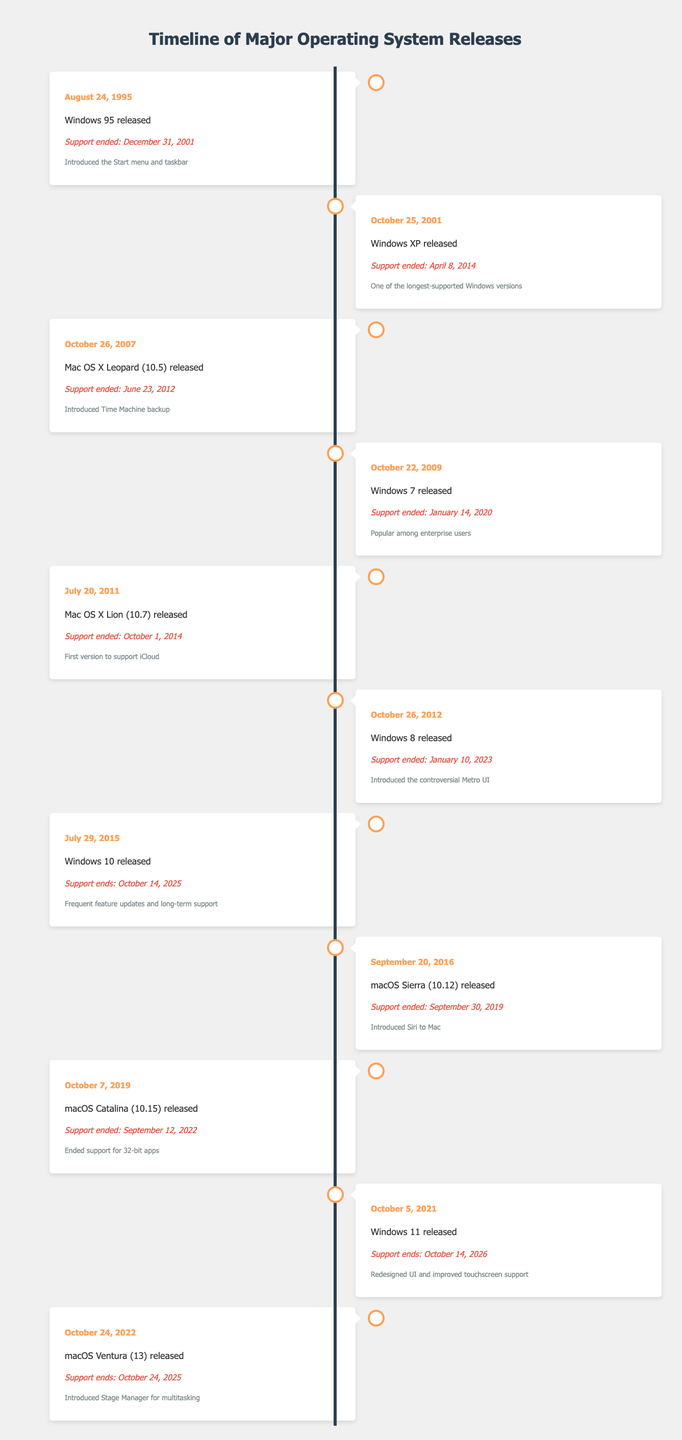What was the support end date for Windows 7? According to the table, Windows 7 was released on October 22, 2009, and the support ended on January 14, 2020, as listed in the support end column.
Answer: January 14, 2020 Which macOS version introduced Siri? The table indicates that macOS Sierra (10.12) released on September 20, 2016, was the version that introduced Siri to Mac, as noted in the observations section for that release.
Answer: macOS Sierra (10.12) How many years did Windows XP receive support? Windows XP was released on October 25, 2001, and its support ended on April 8, 2014. To find the support duration, we calculate the difference between the release date and the support end date: 2014 - 2001 = 13 years, plus the months and days, it totals to around 12 years and 5 months of support.
Answer: Approximately 12 years and 5 months Is macOS Ventura the latest version in the timeline? The timeline presents events up to October 24, 2022, when macOS Ventura (13) was released. Since there are no events listed after this date, we conclude that macOS Ventura is the latest version in this timeline.
Answer: Yes How many operating systems released in 2015 and their support end dates? From the table, only one operating system was released in 2015, which is Windows 10 on July 29, 2015. Its support end date is October 14, 2025. Therefore, there is one OS released in 2015, and the support end date is noted accordingly.
Answer: One OS, October 14, 2025 What is the total duration of support for Windows 8? Windows 8 was released on October 26, 2012, and its support ended on January 10, 2023. To calculate the duration, we'll find the difference between these dates: From October 26, 2012, to October 26, 2022, is 10 years, and from October 26, 2022, to January 10, 2023, is approximately 2 months and 15 days. Hence, totaling this gives around 10 years and 2 months of support.
Answer: Approximately 10 years and 2 months Which operating system had the longest support lifecycle? Reviewing the support end dates for each operating system in the table, Windows XP had the longest lifecycle with support lasting from October 25, 2001, until April 8, 2014, resulting in approximately 12 years and 5 months of support. This is longer compared to other OS releases.
Answer: Windows XP Did Windows 11 receive longer support than Windows 10? Windows 10 is set to be supported until October 14, 2025, while Windows 11 support ends on October 14, 2026. Since October 14, 2026, is a year later than October 14, 2025, it confirms that Windows 11 indeed has longer support than Windows 10.
Answer: Yes 